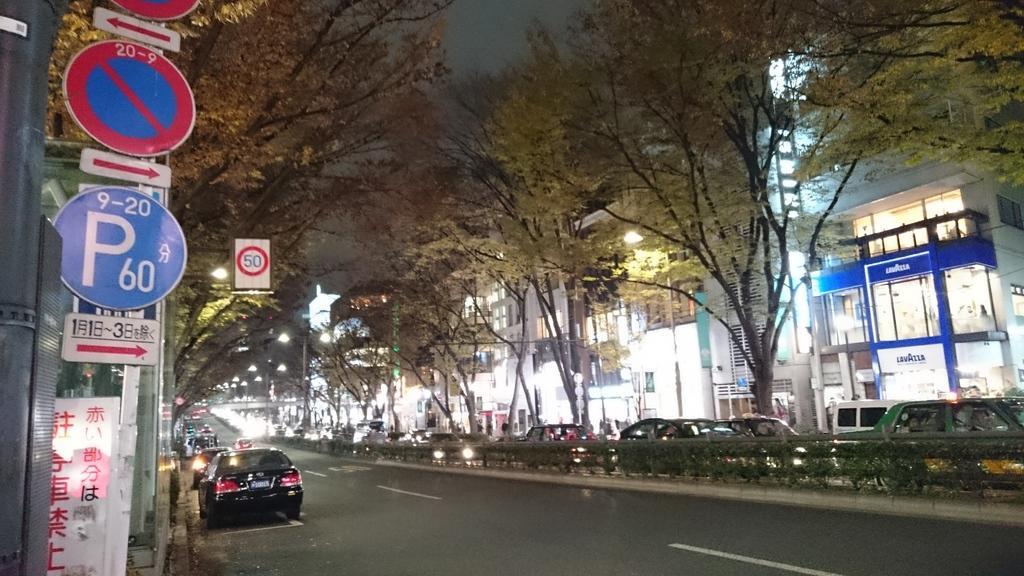Please provide a concise description of this image. This picture is clicked outside. In the center we can see the group of vehicles and we can see the plants, trees, lights and buildings. On the left we can see the boards on which we can see the text and numbers and we can see some other items. 